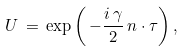Convert formula to latex. <formula><loc_0><loc_0><loc_500><loc_500>U \, = \, \exp \left ( \, - \frac { i \, \gamma } { 2 } \, n \cdot \tau \right ) ,</formula> 